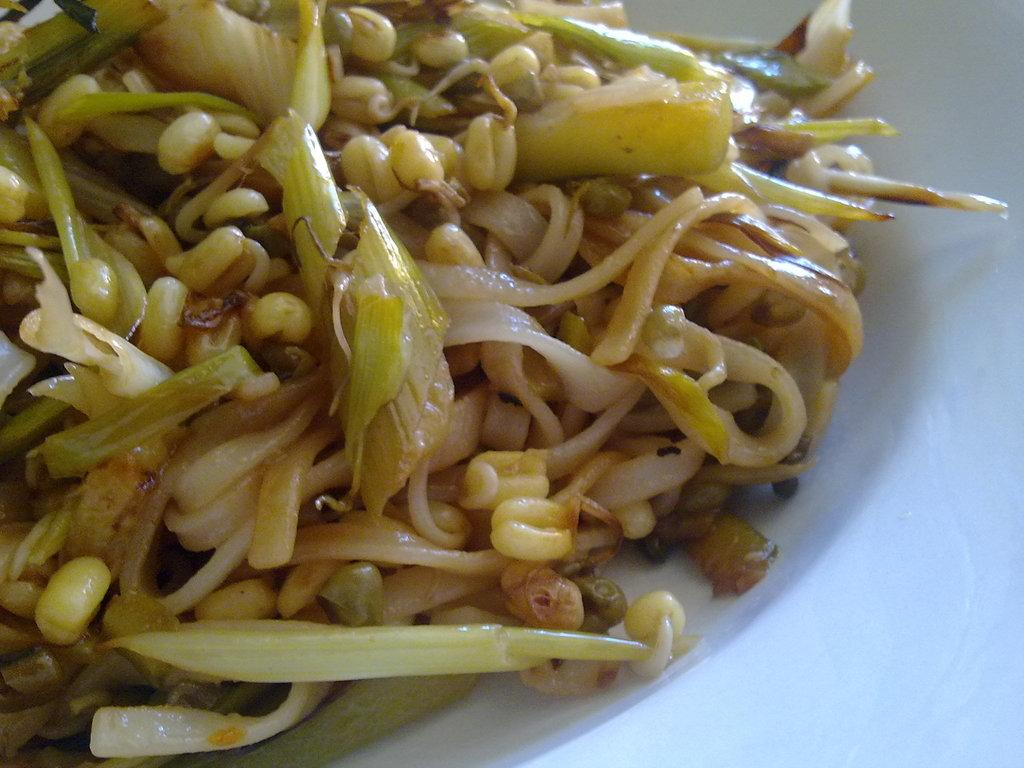What is on the plate in the image? There is a plate in the image, and it contains noodles and other food items. Can you describe the other food items in the plate? Unfortunately, the provided facts do not specify the other food items in the plate. How many plates are visible in the image? The provided facts only mention one plate in the image. What letter is written on the plate in the image? There is no letter written on the plate in the image. What type of stew is being served on the plate in the image? The provided facts do not mention any stew being served on the plate in the image. 